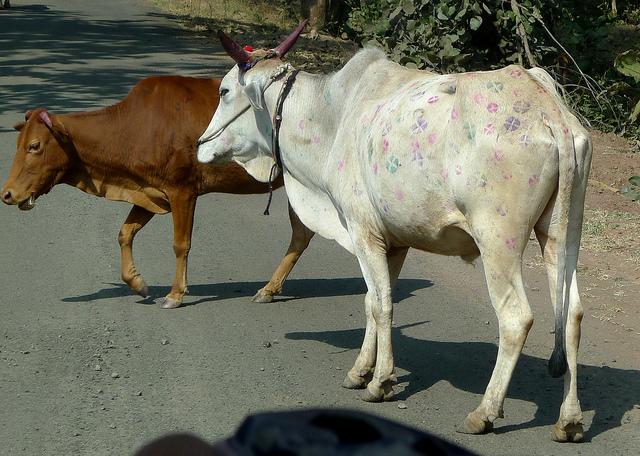Is the picture in color?
Short answer required. Yes. How many cows are on the road?
Answer briefly. 2. Is one of the cows painted?
Short answer required. Yes. Which direction do the cows appear to be looking?
Keep it brief. Left. 